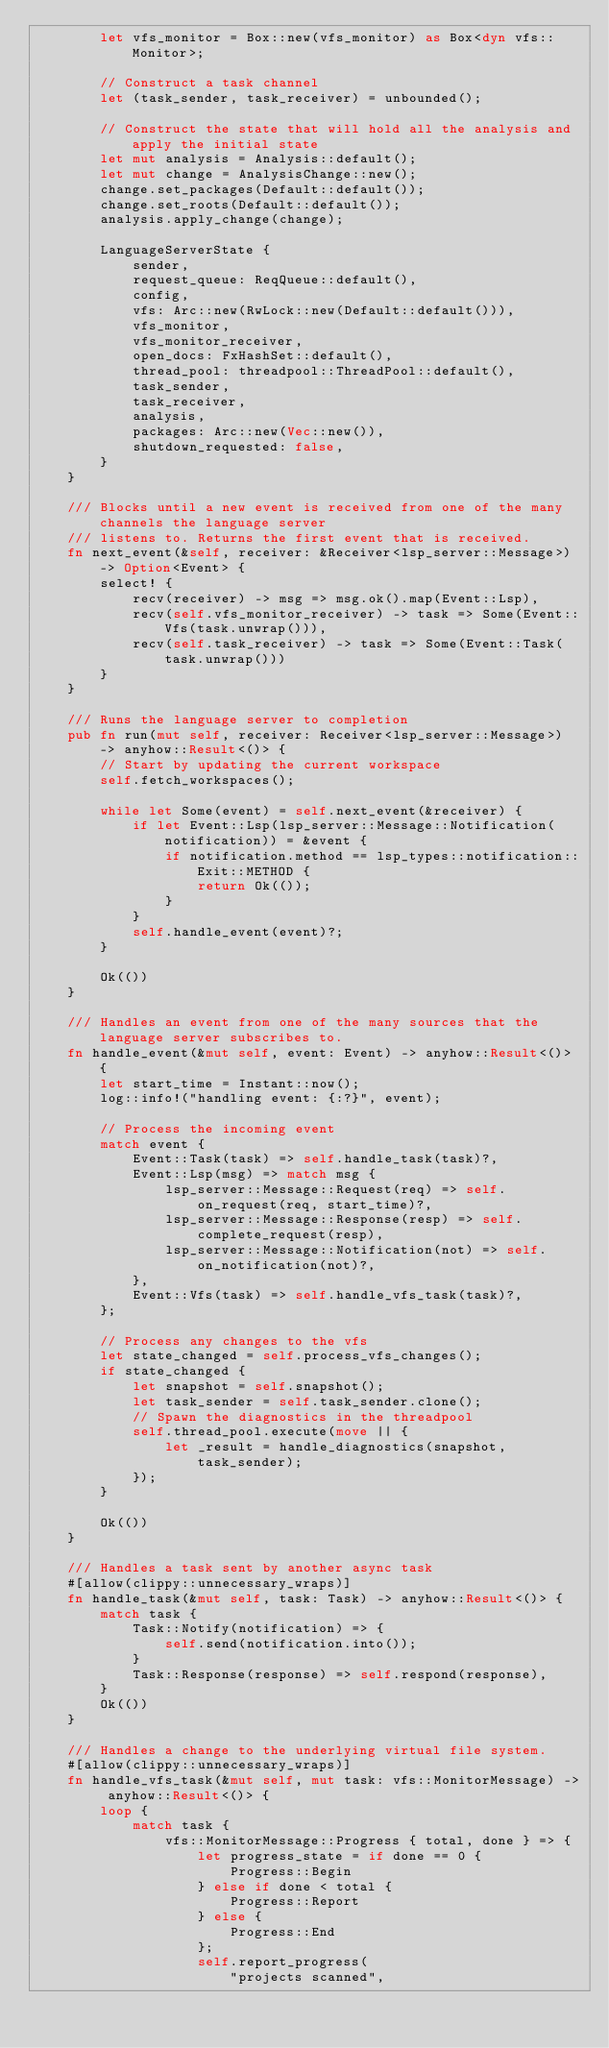Convert code to text. <code><loc_0><loc_0><loc_500><loc_500><_Rust_>        let vfs_monitor = Box::new(vfs_monitor) as Box<dyn vfs::Monitor>;

        // Construct a task channel
        let (task_sender, task_receiver) = unbounded();

        // Construct the state that will hold all the analysis and apply the initial state
        let mut analysis = Analysis::default();
        let mut change = AnalysisChange::new();
        change.set_packages(Default::default());
        change.set_roots(Default::default());
        analysis.apply_change(change);

        LanguageServerState {
            sender,
            request_queue: ReqQueue::default(),
            config,
            vfs: Arc::new(RwLock::new(Default::default())),
            vfs_monitor,
            vfs_monitor_receiver,
            open_docs: FxHashSet::default(),
            thread_pool: threadpool::ThreadPool::default(),
            task_sender,
            task_receiver,
            analysis,
            packages: Arc::new(Vec::new()),
            shutdown_requested: false,
        }
    }

    /// Blocks until a new event is received from one of the many channels the language server
    /// listens to. Returns the first event that is received.
    fn next_event(&self, receiver: &Receiver<lsp_server::Message>) -> Option<Event> {
        select! {
            recv(receiver) -> msg => msg.ok().map(Event::Lsp),
            recv(self.vfs_monitor_receiver) -> task => Some(Event::Vfs(task.unwrap())),
            recv(self.task_receiver) -> task => Some(Event::Task(task.unwrap()))
        }
    }

    /// Runs the language server to completion
    pub fn run(mut self, receiver: Receiver<lsp_server::Message>) -> anyhow::Result<()> {
        // Start by updating the current workspace
        self.fetch_workspaces();

        while let Some(event) = self.next_event(&receiver) {
            if let Event::Lsp(lsp_server::Message::Notification(notification)) = &event {
                if notification.method == lsp_types::notification::Exit::METHOD {
                    return Ok(());
                }
            }
            self.handle_event(event)?;
        }

        Ok(())
    }

    /// Handles an event from one of the many sources that the language server subscribes to.
    fn handle_event(&mut self, event: Event) -> anyhow::Result<()> {
        let start_time = Instant::now();
        log::info!("handling event: {:?}", event);

        // Process the incoming event
        match event {
            Event::Task(task) => self.handle_task(task)?,
            Event::Lsp(msg) => match msg {
                lsp_server::Message::Request(req) => self.on_request(req, start_time)?,
                lsp_server::Message::Response(resp) => self.complete_request(resp),
                lsp_server::Message::Notification(not) => self.on_notification(not)?,
            },
            Event::Vfs(task) => self.handle_vfs_task(task)?,
        };

        // Process any changes to the vfs
        let state_changed = self.process_vfs_changes();
        if state_changed {
            let snapshot = self.snapshot();
            let task_sender = self.task_sender.clone();
            // Spawn the diagnostics in the threadpool
            self.thread_pool.execute(move || {
                let _result = handle_diagnostics(snapshot, task_sender);
            });
        }

        Ok(())
    }

    /// Handles a task sent by another async task
    #[allow(clippy::unnecessary_wraps)]
    fn handle_task(&mut self, task: Task) -> anyhow::Result<()> {
        match task {
            Task::Notify(notification) => {
                self.send(notification.into());
            }
            Task::Response(response) => self.respond(response),
        }
        Ok(())
    }

    /// Handles a change to the underlying virtual file system.
    #[allow(clippy::unnecessary_wraps)]
    fn handle_vfs_task(&mut self, mut task: vfs::MonitorMessage) -> anyhow::Result<()> {
        loop {
            match task {
                vfs::MonitorMessage::Progress { total, done } => {
                    let progress_state = if done == 0 {
                        Progress::Begin
                    } else if done < total {
                        Progress::Report
                    } else {
                        Progress::End
                    };
                    self.report_progress(
                        "projects scanned",</code> 